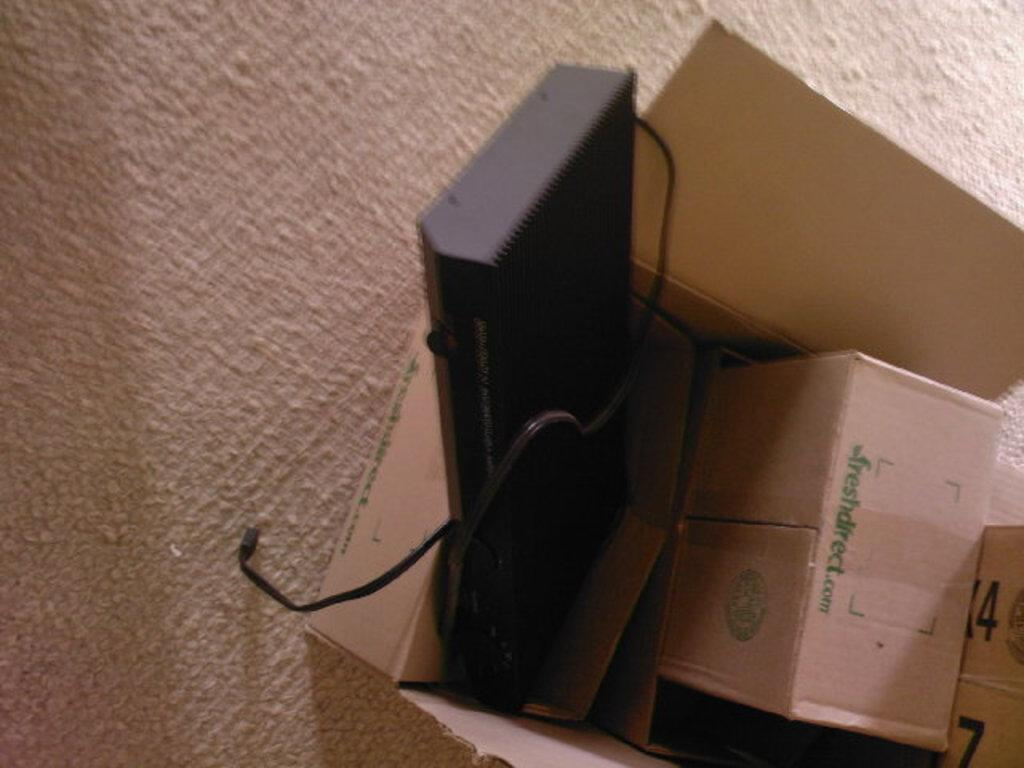What is inside the box that is visible in the image? There is a device in a box in the image. How many boxes are present in the image? There are multiple boxes in the image. What is the color of the surface beneath the boxes? The surface beneath the boxes is creamy in color. What type of cream is being used by the owl in the image? There is no owl present in the image, and therefore no cream or owl-related activities can be observed. 